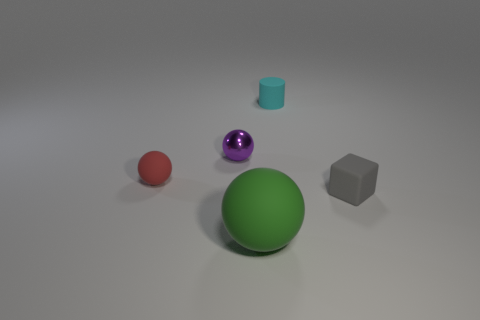What shape is the other red thing that is the same size as the metallic thing?
Provide a short and direct response. Sphere. What is the shape of the small rubber object left of the object in front of the gray rubber block?
Offer a terse response. Sphere. Is the number of purple spheres that are left of the gray thing less than the number of small rubber objects to the left of the green object?
Ensure brevity in your answer.  No. What size is the red rubber object that is the same shape as the purple metal thing?
Offer a very short reply. Small. Are there any other things that have the same size as the green ball?
Your response must be concise. No. What number of things are tiny rubber objects right of the small red matte object or tiny balls that are behind the red matte object?
Offer a very short reply. 3. Is the gray object the same size as the cylinder?
Your response must be concise. Yes. Is the number of purple metallic objects greater than the number of rubber balls?
Make the answer very short. No. What number of other objects are there of the same color as the large object?
Offer a very short reply. 0. What number of objects are tiny cyan matte objects or green matte objects?
Offer a terse response. 2. 